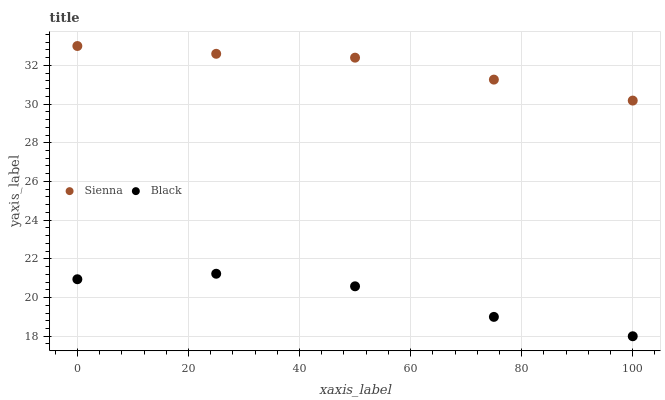Does Black have the minimum area under the curve?
Answer yes or no. Yes. Does Sienna have the maximum area under the curve?
Answer yes or no. Yes. Does Black have the maximum area under the curve?
Answer yes or no. No. Is Sienna the smoothest?
Answer yes or no. Yes. Is Black the roughest?
Answer yes or no. Yes. Is Black the smoothest?
Answer yes or no. No. Does Black have the lowest value?
Answer yes or no. Yes. Does Sienna have the highest value?
Answer yes or no. Yes. Does Black have the highest value?
Answer yes or no. No. Is Black less than Sienna?
Answer yes or no. Yes. Is Sienna greater than Black?
Answer yes or no. Yes. Does Black intersect Sienna?
Answer yes or no. No. 